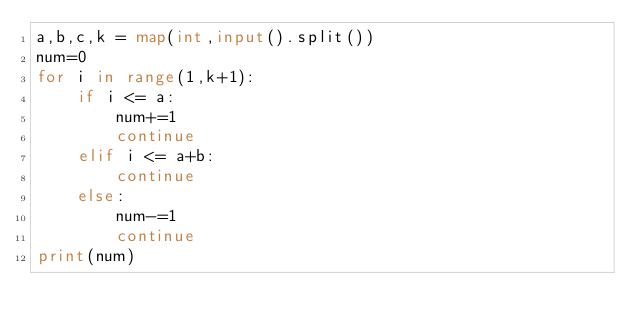<code> <loc_0><loc_0><loc_500><loc_500><_Python_>a,b,c,k = map(int,input().split())
num=0
for i in range(1,k+1):
    if i <= a:
        num+=1
        continue
    elif i <= a+b:
        continue
    else:
        num-=1
        continue
print(num)

</code> 